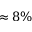<formula> <loc_0><loc_0><loc_500><loc_500>\approx 8 \%</formula> 